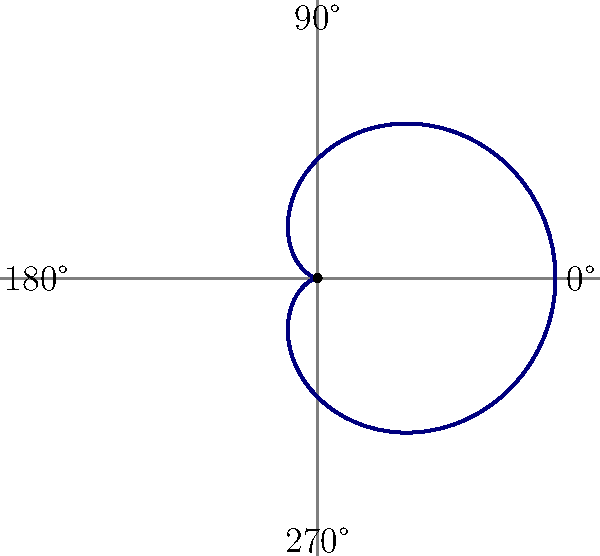In the polar pattern shown above for a cardioid microphone, at which angle does the microphone exhibit its maximum sensitivity, and how does this relate to the microphone's placement during a vocal recording session? To answer this question, let's analyze the polar pattern step-by-step:

1. The polar pattern shown is that of a cardioid microphone, which is heart-shaped.

2. In a cardioid pattern, the maximum sensitivity is at 0° (on-axis), which is directly in front of the microphone.

3. The pattern shows:
   - Maximum pickup at 0°
   - Reduced sensitivity at 90° and 270°
   - Minimum pickup (null point) at 180°

4. The cardioid pattern provides:
   - High sensitivity to sounds from the front
   - Moderate sensitivity to sounds from the sides
   - Low sensitivity to sounds from the rear

5. In a vocal recording session, this characteristic is advantageous because:
   - The vocalist should be positioned directly in front of the microphone (at 0°) for maximum pickup.
   - It helps to reject unwanted sounds from the rear, such as room reflections or other instruments.
   - It offers some isolation from sounds coming from the sides, which can be useful in a studio environment.

6. For a meticulous producer/singer-songwriter, understanding this pattern allows for:
   - Precise microphone placement for optimal vocal capture
   - Minimizing unwanted room acoustics in the recording
   - Potentially reducing the need for extensive post-production processing

Therefore, the cardioid microphone's maximum sensitivity at 0° directly informs its ideal placement for vocal recording, ensuring the clearest and most direct capture of the singer's voice while minimizing unwanted ambient sounds.
Answer: 0°; placed directly in front of the vocalist for maximum sensitivity and rejection of rear sounds. 